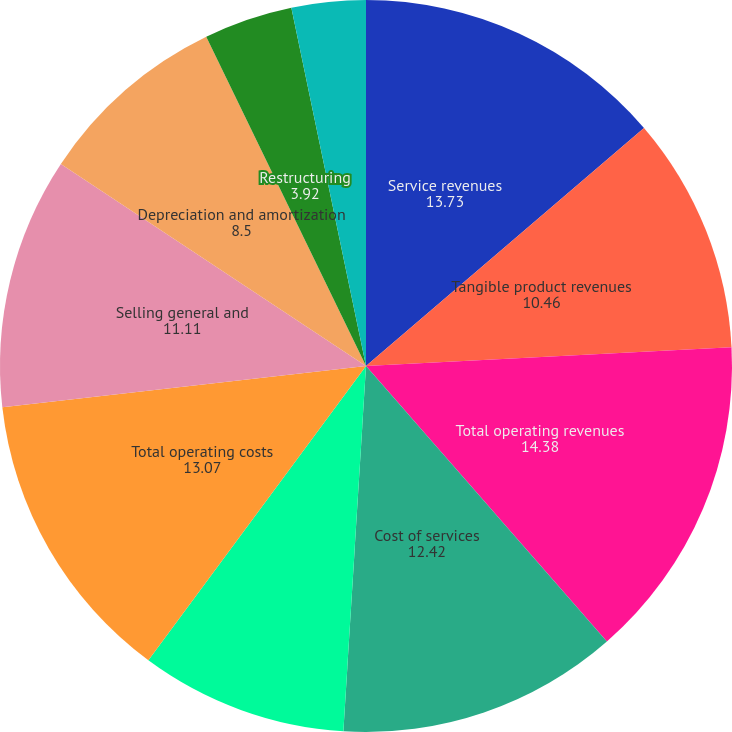Convert chart to OTSL. <chart><loc_0><loc_0><loc_500><loc_500><pie_chart><fcel>Service revenues<fcel>Tangible product revenues<fcel>Total operating revenues<fcel>Cost of services<fcel>Cost of tangible products<fcel>Total operating costs<fcel>Selling general and<fcel>Depreciation and amortization<fcel>Restructuring<fcel>(Income) expense from<nl><fcel>13.73%<fcel>10.46%<fcel>14.38%<fcel>12.42%<fcel>9.15%<fcel>13.07%<fcel>11.11%<fcel>8.5%<fcel>3.92%<fcel>3.27%<nl></chart> 